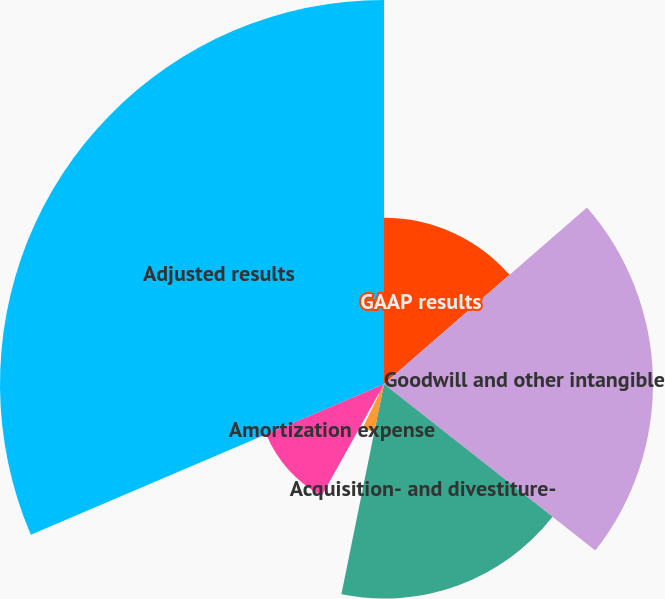<chart> <loc_0><loc_0><loc_500><loc_500><pie_chart><fcel>GAAP results<fcel>Goodwill and other intangible<fcel>Acquisition- and divestiture-<fcel>Restructuring-related charges<fcel>Litigation-related charges<fcel>Amortization expense<fcel>Adjusted results<nl><fcel>13.61%<fcel>22.01%<fcel>17.56%<fcel>3.98%<fcel>0.93%<fcel>10.49%<fcel>31.42%<nl></chart> 